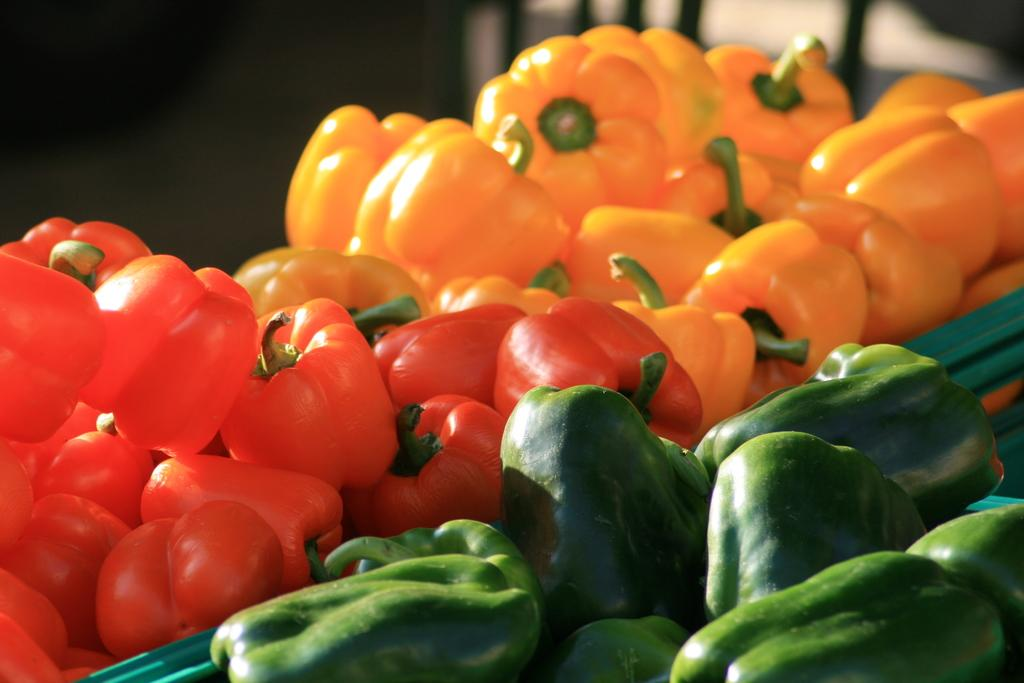What types of capsicums can be seen in the foreground of the image? There are red, yellow, and green capsicums in the foreground of the image. Can you describe the colors of the capsicums? The capsicums have red, yellow, and green colors. Are there any other types of capsicums visible in the image? No, the image only shows red, yellow, and green capsicums in the foreground. How many friends does the stomach have in the image? There are no friends or stomachs present in the image; it only features capsicums. Can you tell me what type of beetle is crawling on the yellow capsicum? There is no beetle present on the yellow capsicum or any other capsicum in the image. 